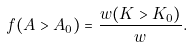Convert formula to latex. <formula><loc_0><loc_0><loc_500><loc_500>f ( A > A _ { 0 } ) = \frac { w ( { K > K _ { 0 } } ) } { w } .</formula> 